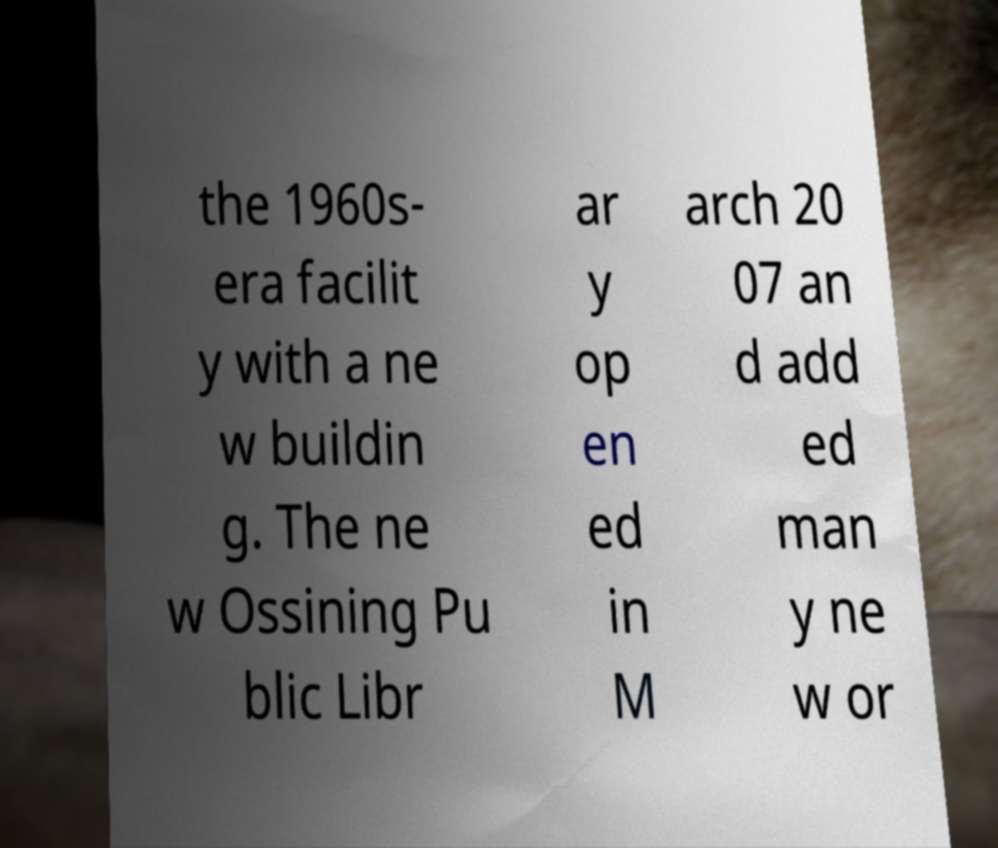What messages or text are displayed in this image? I need them in a readable, typed format. the 1960s- era facilit y with a ne w buildin g. The ne w Ossining Pu blic Libr ar y op en ed in M arch 20 07 an d add ed man y ne w or 